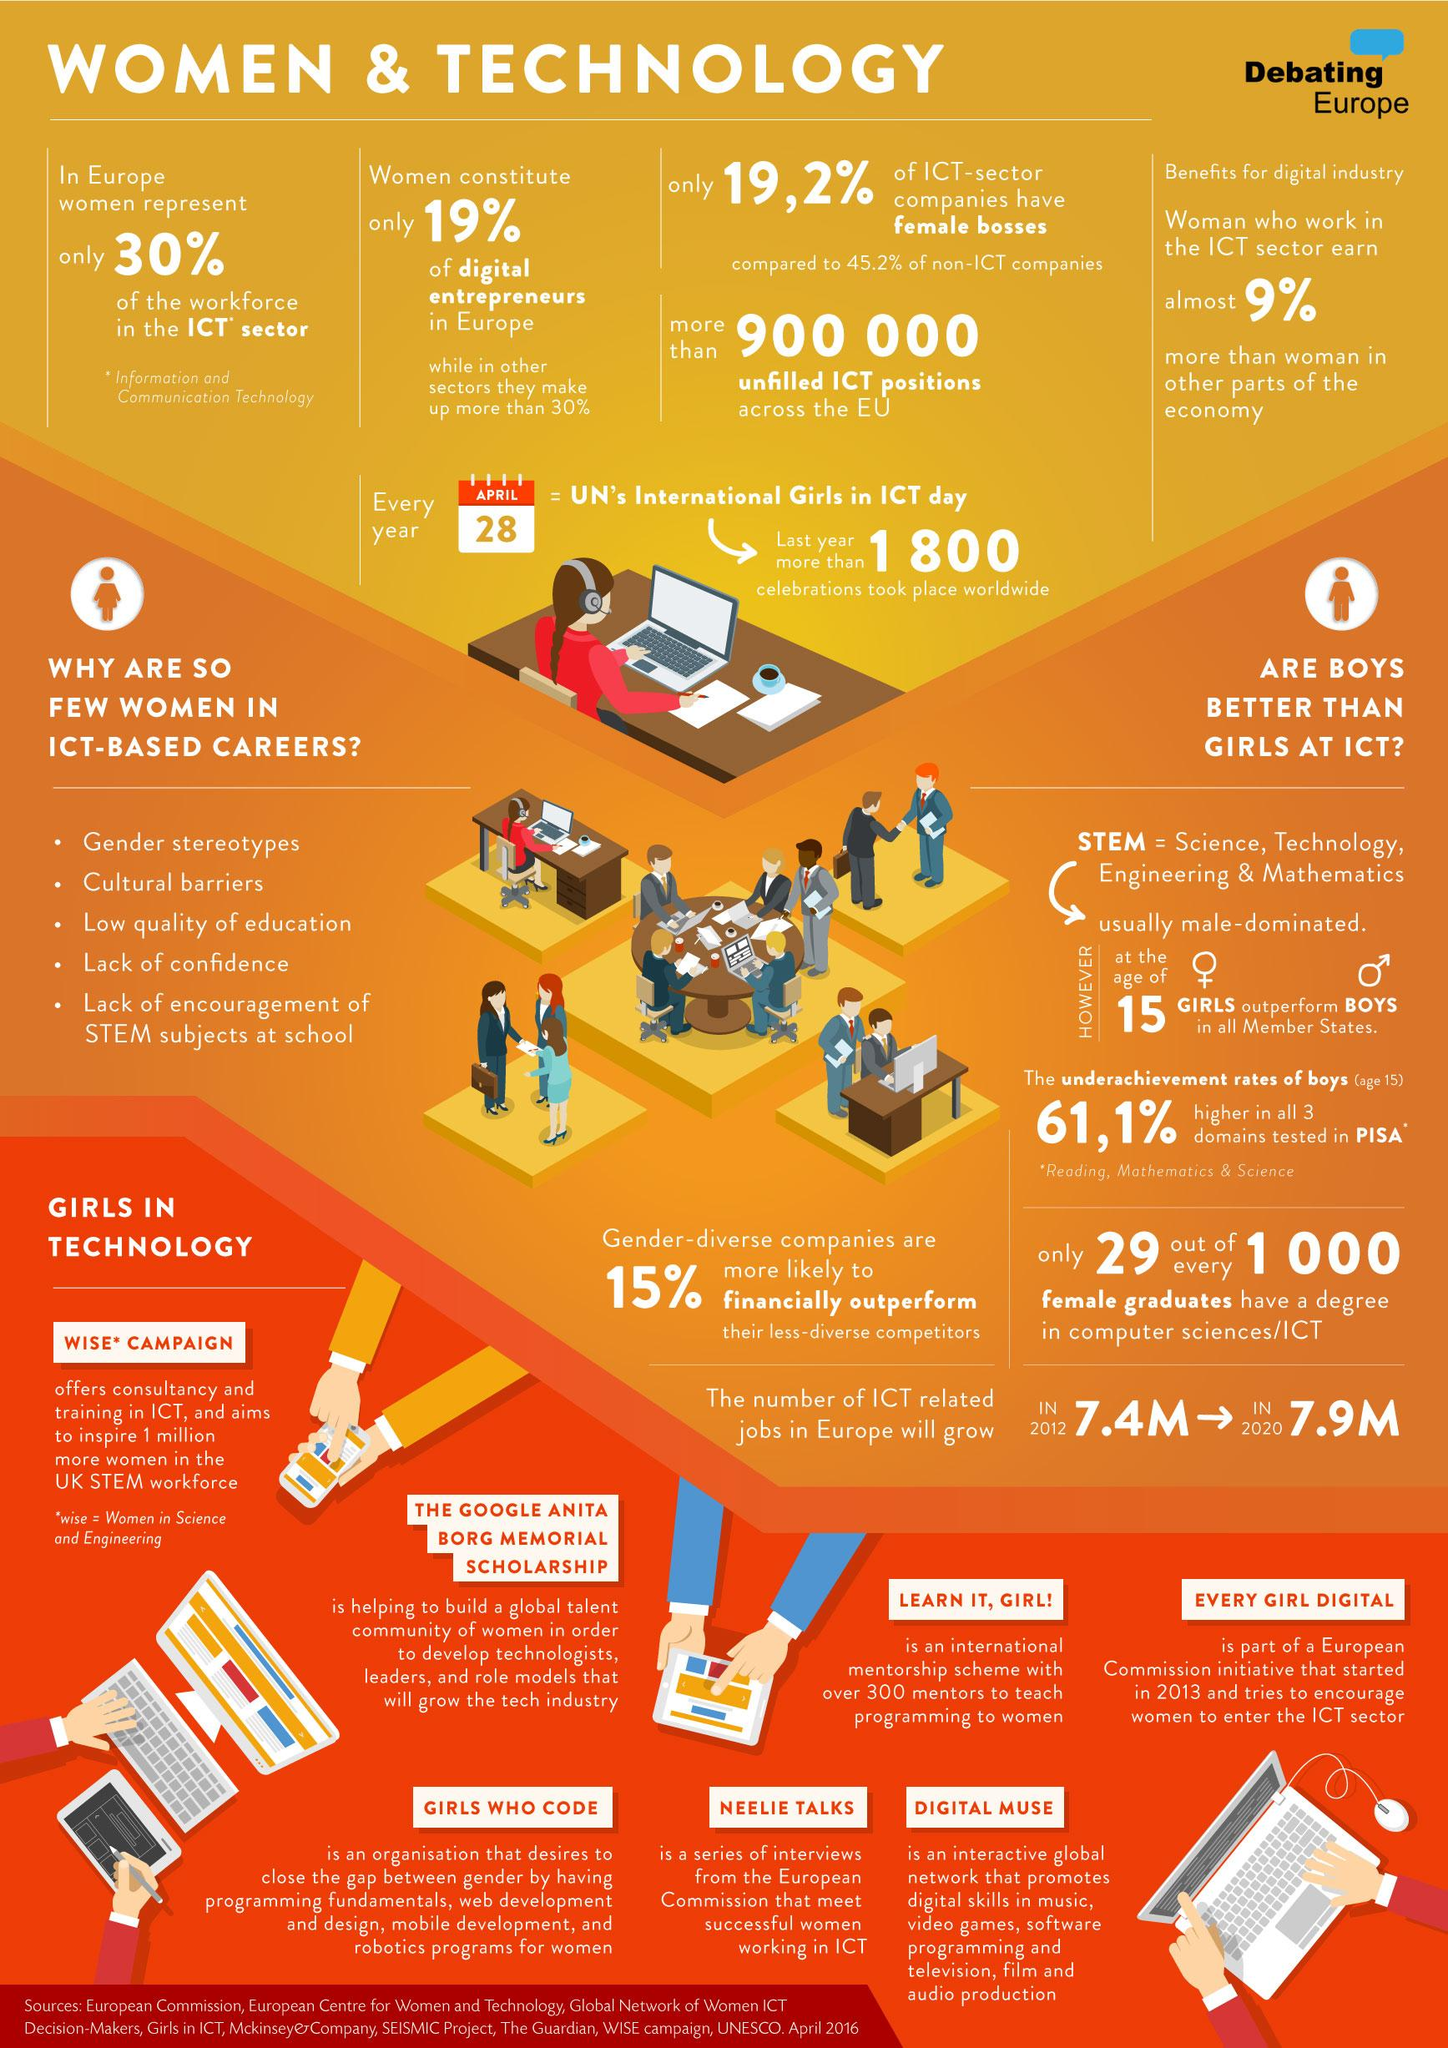Draw attention to some important aspects in this diagram. According to recent data, the percentage of women entrepreneurs in Europe's digital companies is 19%. 